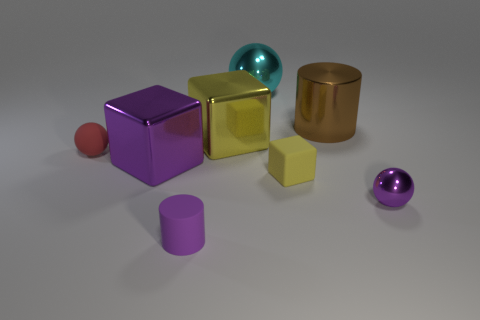Does the big brown object have the same shape as the yellow thing that is in front of the red rubber ball?
Your response must be concise. No. How many rubber things are both behind the tiny matte cylinder and on the left side of the yellow shiny thing?
Offer a terse response. 1. Are the small purple cylinder and the cylinder that is behind the tiny metal ball made of the same material?
Provide a short and direct response. No. Are there the same number of big brown cylinders in front of the tiny yellow thing and big red metal cubes?
Your response must be concise. Yes. There is a metallic cube left of the small purple rubber thing; what is its color?
Your answer should be compact. Purple. How many other things are there of the same color as the big cylinder?
Ensure brevity in your answer.  0. Is there anything else that has the same size as the brown shiny cylinder?
Provide a succinct answer. Yes. There is a yellow block that is on the left side of the cyan sphere; is its size the same as the cyan metallic sphere?
Offer a very short reply. Yes. There is a small purple object on the left side of the brown thing; what is its material?
Your answer should be compact. Rubber. How many metallic objects are either blue blocks or yellow things?
Keep it short and to the point. 1. 